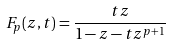<formula> <loc_0><loc_0><loc_500><loc_500>F _ { p } ( z , t ) = \frac { t z } { 1 - z - t z ^ { p + 1 } }</formula> 